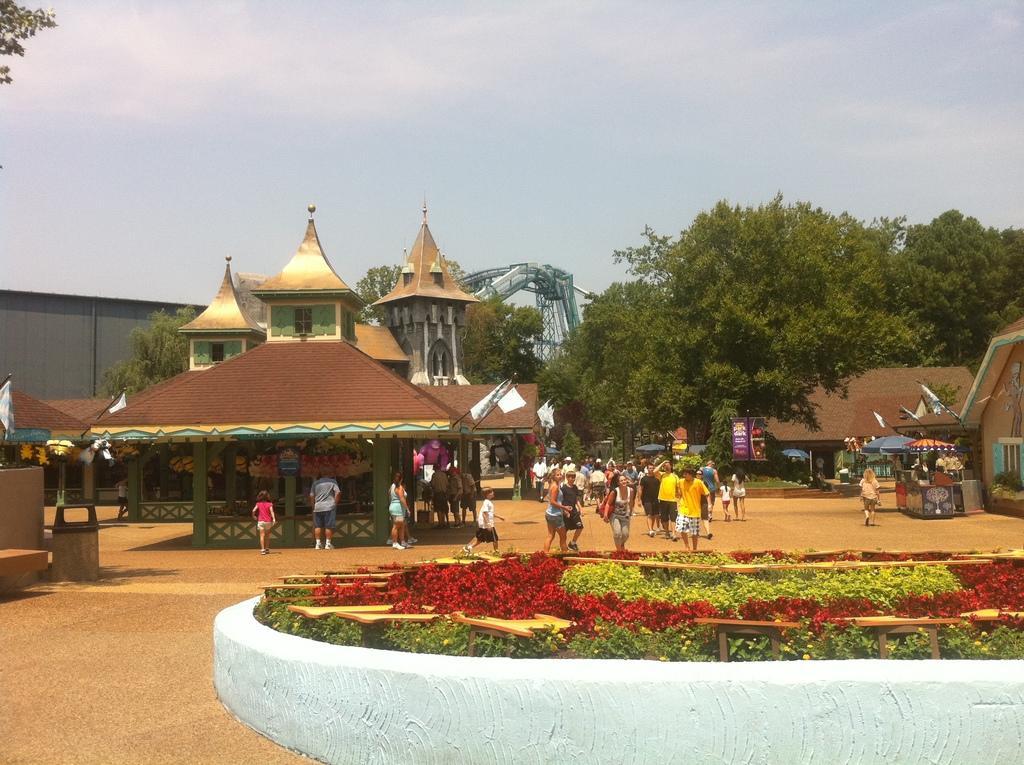What type of natural elements can be seen in the image? There are flowers in the image. What are the people in the image doing? People are standing on the road in the image. What can be seen in the background of the image? There are buildings, trees, and the sky visible in the background of the image. What type of cushion can be seen floating on the waves in the image? There are no waves or cushions present in the image. 